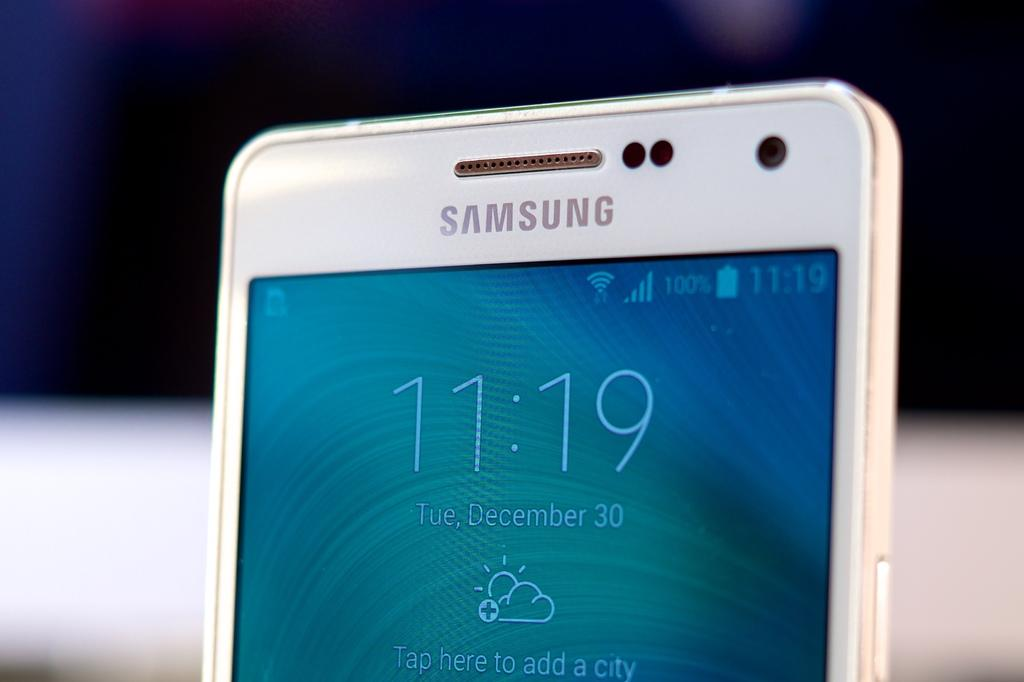<image>
Provide a brief description of the given image. A white Samsung smartphone shows the time is 11:19. 